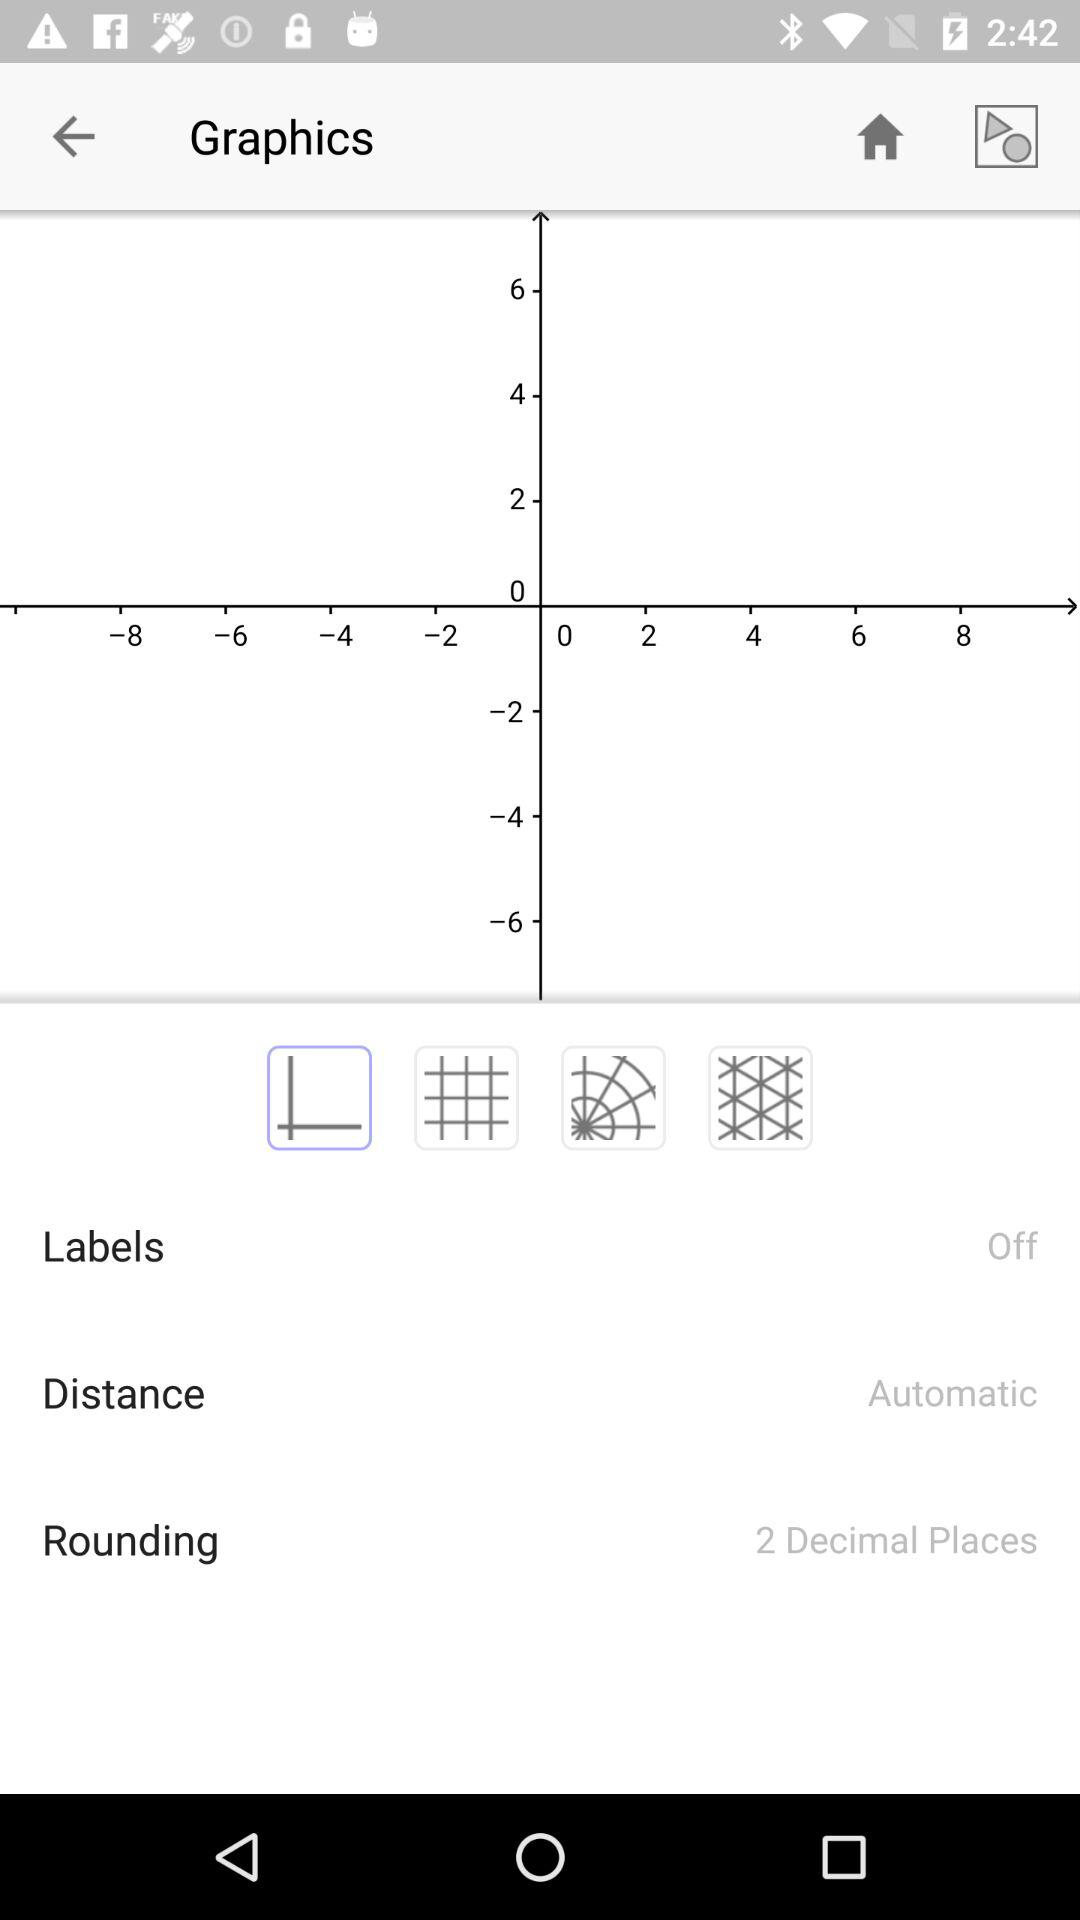What is the status of the "Labels"? The status is "off". 